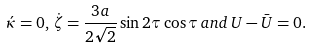<formula> <loc_0><loc_0><loc_500><loc_500>\acute { \kappa } = 0 , \, \dot { \zeta } = \frac { 3 a } { 2 \sqrt { 2 } } \sin 2 \tau \cos \tau \, a n d \, U - \bar { U } = 0 .</formula> 